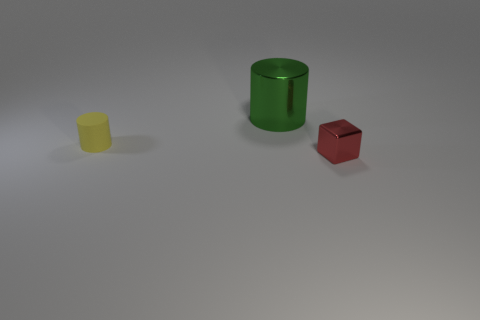What is the color of the other tiny rubber object that is the same shape as the green object?
Keep it short and to the point. Yellow. Is the red thing the same shape as the green object?
Your answer should be compact. No. What is the material of the small yellow cylinder?
Provide a short and direct response. Rubber. Do the tiny thing that is in front of the small yellow cylinder and the large green metallic object have the same shape?
Your answer should be very brief. No. How many things are either tiny red things or yellow cylinders?
Provide a short and direct response. 2. Does the object in front of the yellow cylinder have the same material as the big green cylinder?
Your response must be concise. Yes. How big is the shiny cube?
Keep it short and to the point. Small. What number of blocks are either metal objects or large objects?
Ensure brevity in your answer.  1. Are there the same number of tiny red shiny objects behind the tiny yellow rubber object and metallic things that are in front of the shiny block?
Keep it short and to the point. Yes. What is the size of the other object that is the same shape as the big green object?
Offer a terse response. Small. 